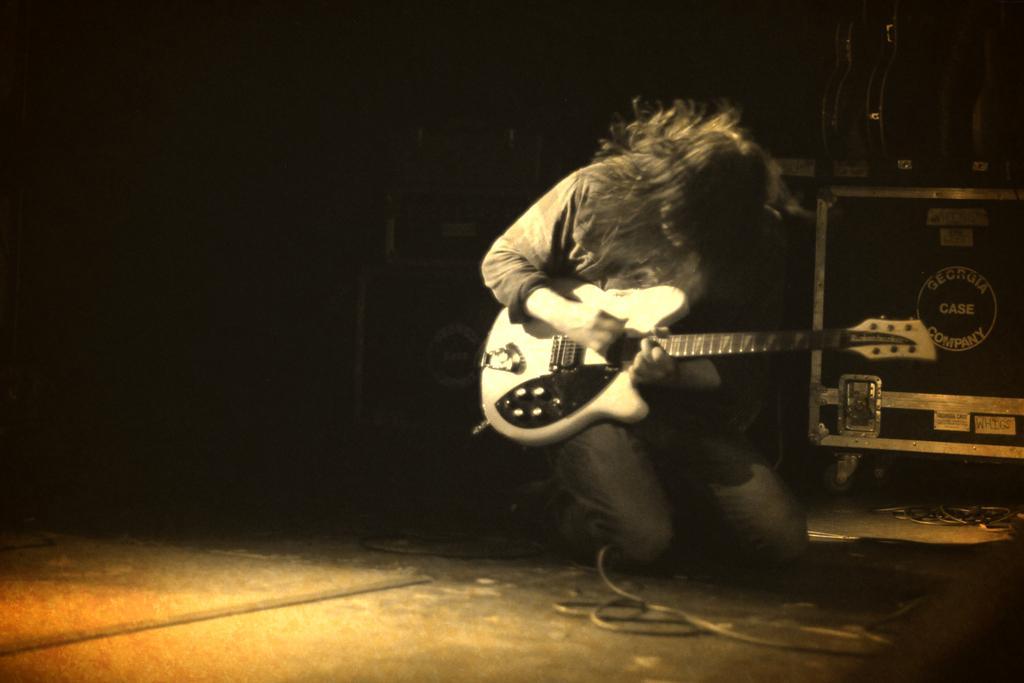How would you summarize this image in a sentence or two? In this image I can see a person holding the guitar. 